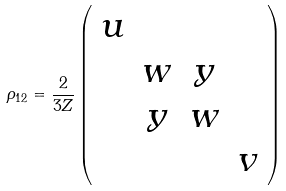<formula> <loc_0><loc_0><loc_500><loc_500>\rho _ { 1 2 } = \frac { 2 } { 3 Z } \left ( \begin{array} { c c c c } u & & & \\ & w & y & \\ & y & w & \\ & & & v \end{array} \right )</formula> 